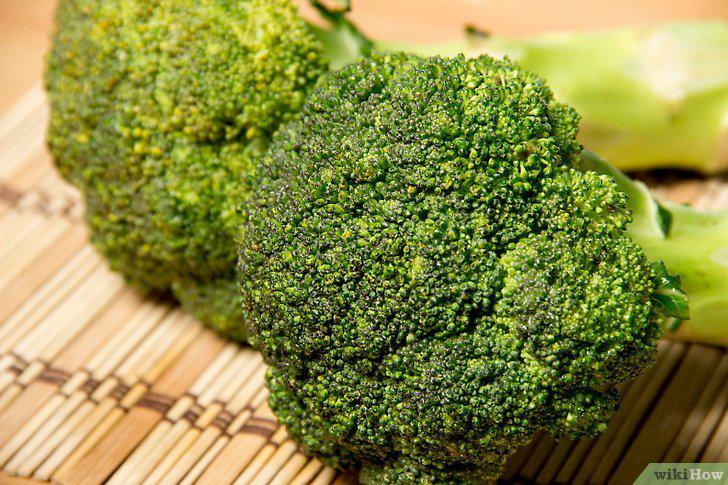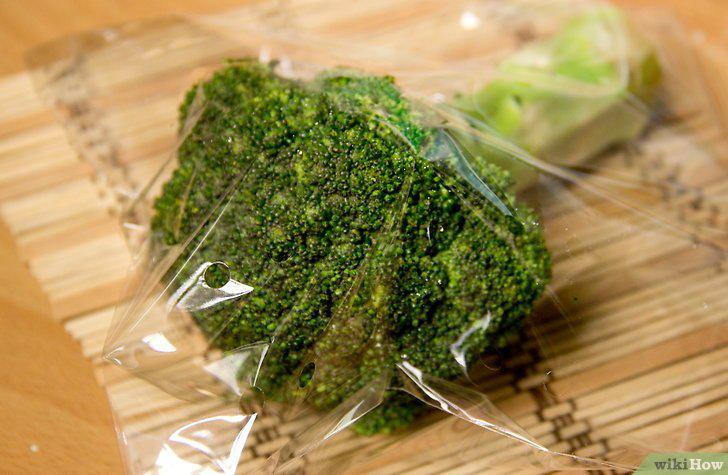The first image is the image on the left, the second image is the image on the right. Examine the images to the left and right. Is the description "The right image shows a stalk of broccoli inside of a cup." accurate? Answer yes or no. No. 